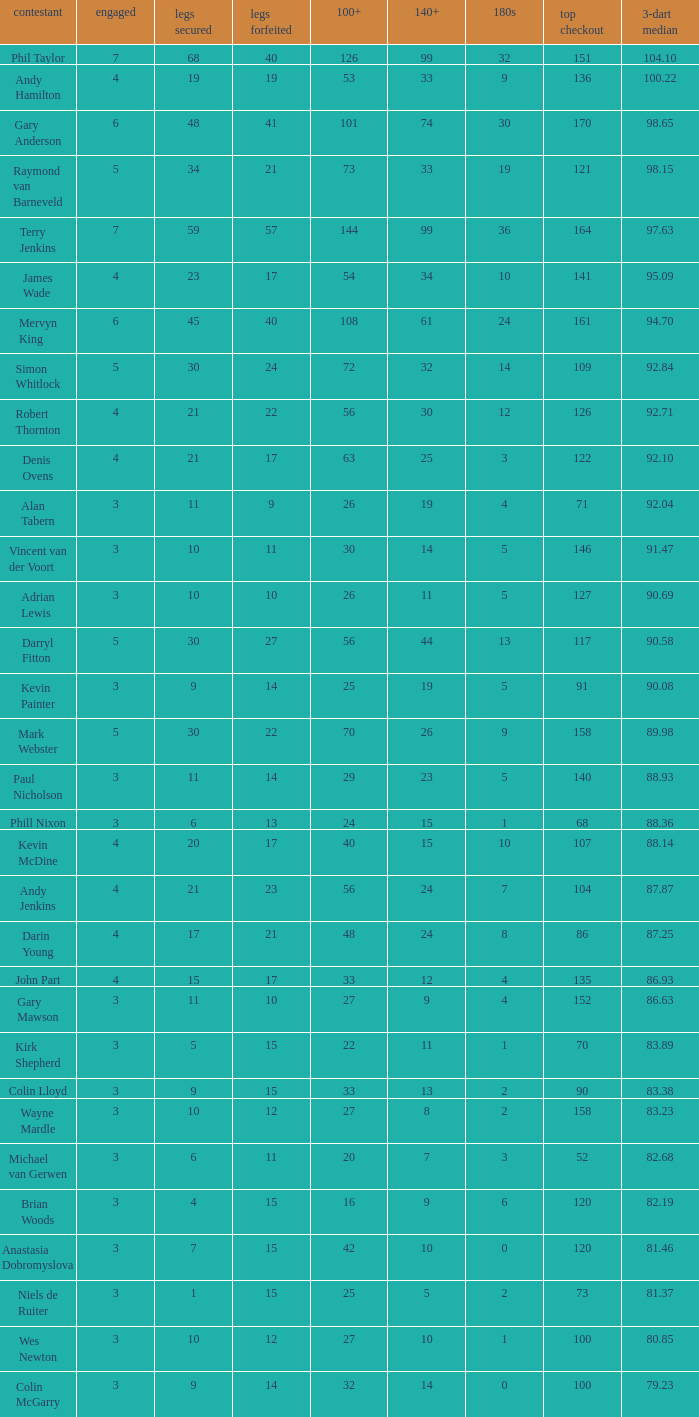What is the high checkout when Legs Won is smaller than 9, a 180s of 1, and a 3-dart Average larger than 88.36? None. 